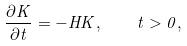<formula> <loc_0><loc_0><loc_500><loc_500>\frac { \partial K } { \partial t } = - H K , \quad t > 0 ,</formula> 